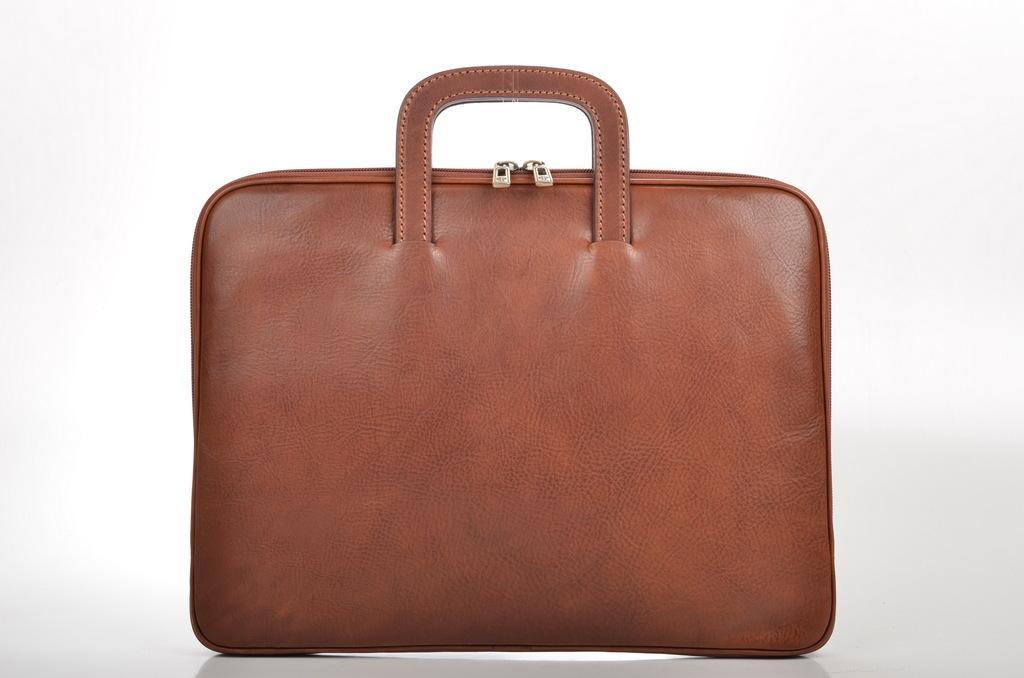Can you describe this image briefly? This is a image of a leather hand bag or a bag containing of 2 zips and a holder. 